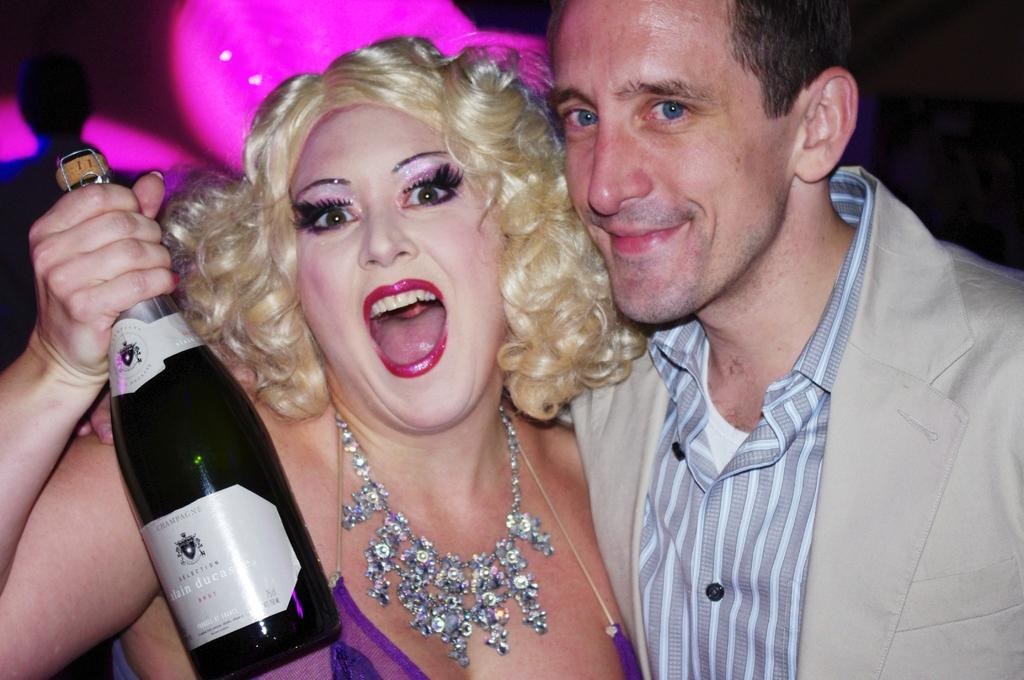Who are the people in the foreground of the image? There is a man and a woman in the foreground of the image. What is the woman holding in the image? The woman is holding a bottle in the image. What is the woman doing in the image? The woman is screaming in the image. What can be seen in the background of the image? There are objects in the background of the image. What type of scent is coming from the scarecrow in the image? There is no scarecrow present in the image, so it is not possible to determine the scent coming from it. 